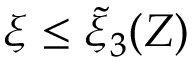<formula> <loc_0><loc_0><loc_500><loc_500>\xi \leq \tilde { \xi } _ { 3 } ( Z )</formula> 